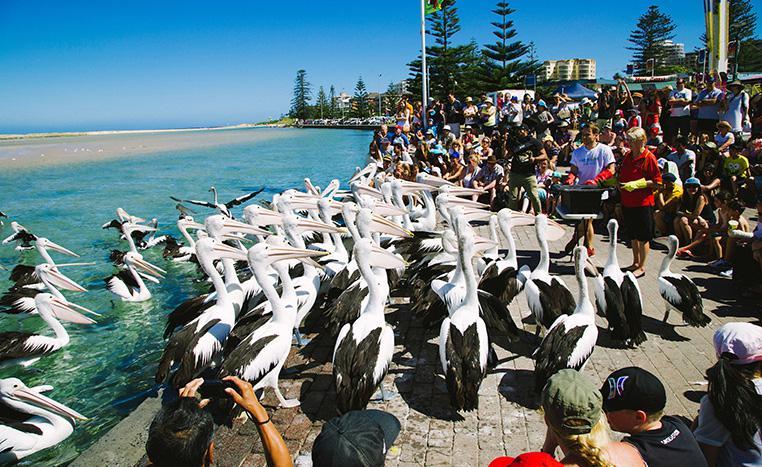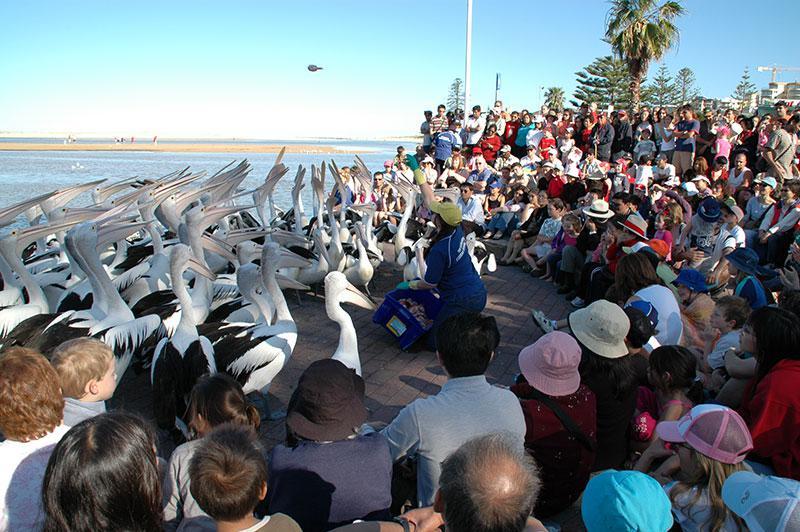The first image is the image on the left, the second image is the image on the right. Considering the images on both sides, is "There are at least eight pelicans facing left with no more than four people visible in the right side of the photo." valid? Answer yes or no. No. The first image is the image on the left, the second image is the image on the right. Considering the images on both sides, is "In at least one of the images, every single bird is facing to the left." valid? Answer yes or no. No. 